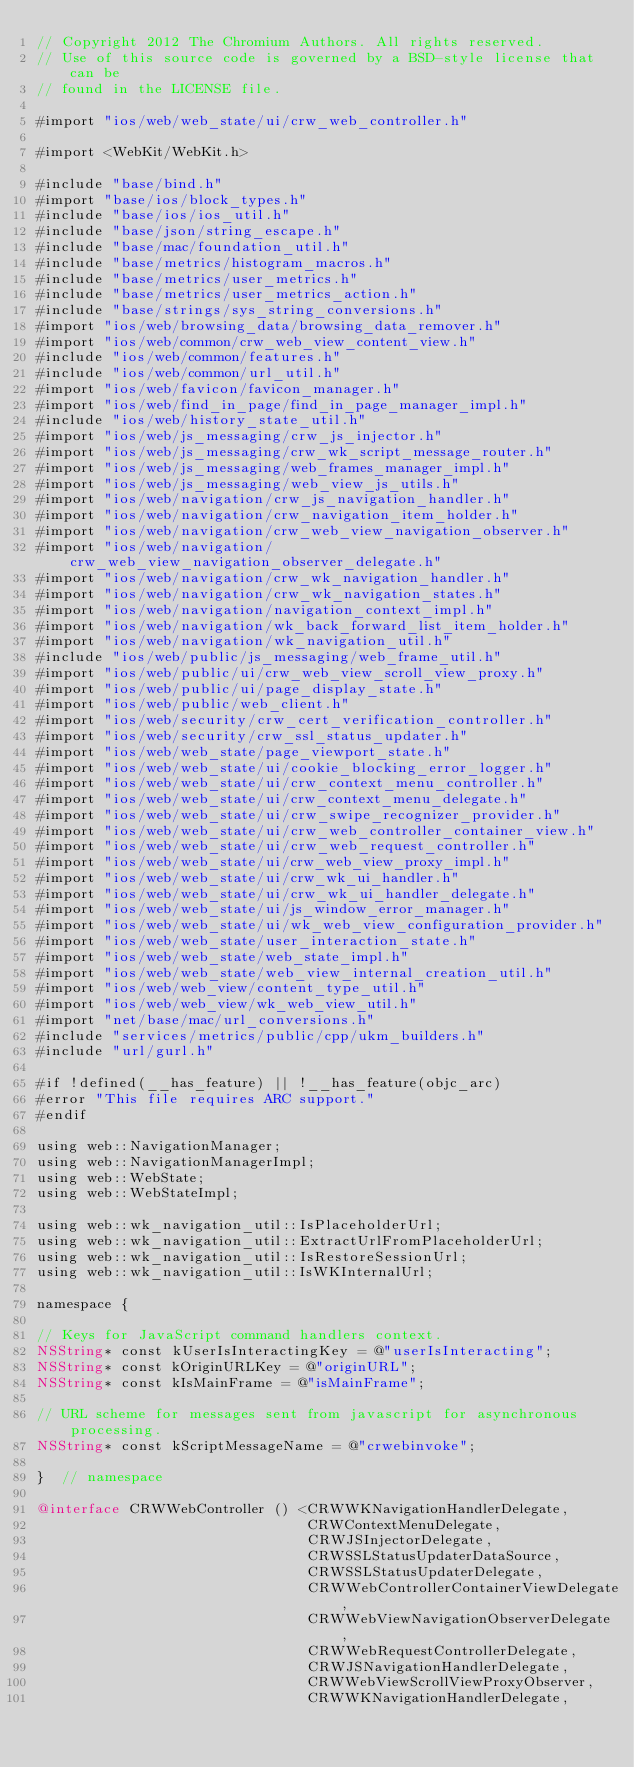Convert code to text. <code><loc_0><loc_0><loc_500><loc_500><_ObjectiveC_>// Copyright 2012 The Chromium Authors. All rights reserved.
// Use of this source code is governed by a BSD-style license that can be
// found in the LICENSE file.

#import "ios/web/web_state/ui/crw_web_controller.h"

#import <WebKit/WebKit.h>

#include "base/bind.h"
#import "base/ios/block_types.h"
#include "base/ios/ios_util.h"
#include "base/json/string_escape.h"
#include "base/mac/foundation_util.h"
#include "base/metrics/histogram_macros.h"
#include "base/metrics/user_metrics.h"
#include "base/metrics/user_metrics_action.h"
#include "base/strings/sys_string_conversions.h"
#import "ios/web/browsing_data/browsing_data_remover.h"
#import "ios/web/common/crw_web_view_content_view.h"
#include "ios/web/common/features.h"
#include "ios/web/common/url_util.h"
#import "ios/web/favicon/favicon_manager.h"
#import "ios/web/find_in_page/find_in_page_manager_impl.h"
#include "ios/web/history_state_util.h"
#import "ios/web/js_messaging/crw_js_injector.h"
#import "ios/web/js_messaging/crw_wk_script_message_router.h"
#import "ios/web/js_messaging/web_frames_manager_impl.h"
#import "ios/web/js_messaging/web_view_js_utils.h"
#import "ios/web/navigation/crw_js_navigation_handler.h"
#import "ios/web/navigation/crw_navigation_item_holder.h"
#import "ios/web/navigation/crw_web_view_navigation_observer.h"
#import "ios/web/navigation/crw_web_view_navigation_observer_delegate.h"
#import "ios/web/navigation/crw_wk_navigation_handler.h"
#import "ios/web/navigation/crw_wk_navigation_states.h"
#import "ios/web/navigation/navigation_context_impl.h"
#import "ios/web/navigation/wk_back_forward_list_item_holder.h"
#import "ios/web/navigation/wk_navigation_util.h"
#include "ios/web/public/js_messaging/web_frame_util.h"
#import "ios/web/public/ui/crw_web_view_scroll_view_proxy.h"
#import "ios/web/public/ui/page_display_state.h"
#import "ios/web/public/web_client.h"
#import "ios/web/security/crw_cert_verification_controller.h"
#import "ios/web/security/crw_ssl_status_updater.h"
#import "ios/web/web_state/page_viewport_state.h"
#import "ios/web/web_state/ui/cookie_blocking_error_logger.h"
#import "ios/web/web_state/ui/crw_context_menu_controller.h"
#import "ios/web/web_state/ui/crw_context_menu_delegate.h"
#import "ios/web/web_state/ui/crw_swipe_recognizer_provider.h"
#import "ios/web/web_state/ui/crw_web_controller_container_view.h"
#import "ios/web/web_state/ui/crw_web_request_controller.h"
#import "ios/web/web_state/ui/crw_web_view_proxy_impl.h"
#import "ios/web/web_state/ui/crw_wk_ui_handler.h"
#import "ios/web/web_state/ui/crw_wk_ui_handler_delegate.h"
#import "ios/web/web_state/ui/js_window_error_manager.h"
#import "ios/web/web_state/ui/wk_web_view_configuration_provider.h"
#import "ios/web/web_state/user_interaction_state.h"
#import "ios/web/web_state/web_state_impl.h"
#import "ios/web/web_state/web_view_internal_creation_util.h"
#import "ios/web/web_view/content_type_util.h"
#import "ios/web/web_view/wk_web_view_util.h"
#import "net/base/mac/url_conversions.h"
#include "services/metrics/public/cpp/ukm_builders.h"
#include "url/gurl.h"

#if !defined(__has_feature) || !__has_feature(objc_arc)
#error "This file requires ARC support."
#endif

using web::NavigationManager;
using web::NavigationManagerImpl;
using web::WebState;
using web::WebStateImpl;

using web::wk_navigation_util::IsPlaceholderUrl;
using web::wk_navigation_util::ExtractUrlFromPlaceholderUrl;
using web::wk_navigation_util::IsRestoreSessionUrl;
using web::wk_navigation_util::IsWKInternalUrl;

namespace {

// Keys for JavaScript command handlers context.
NSString* const kUserIsInteractingKey = @"userIsInteracting";
NSString* const kOriginURLKey = @"originURL";
NSString* const kIsMainFrame = @"isMainFrame";

// URL scheme for messages sent from javascript for asynchronous processing.
NSString* const kScriptMessageName = @"crwebinvoke";

}  // namespace

@interface CRWWebController () <CRWWKNavigationHandlerDelegate,
                                CRWContextMenuDelegate,
                                CRWJSInjectorDelegate,
                                CRWSSLStatusUpdaterDataSource,
                                CRWSSLStatusUpdaterDelegate,
                                CRWWebControllerContainerViewDelegate,
                                CRWWebViewNavigationObserverDelegate,
                                CRWWebRequestControllerDelegate,
                                CRWJSNavigationHandlerDelegate,
                                CRWWebViewScrollViewProxyObserver,
                                CRWWKNavigationHandlerDelegate,</code> 